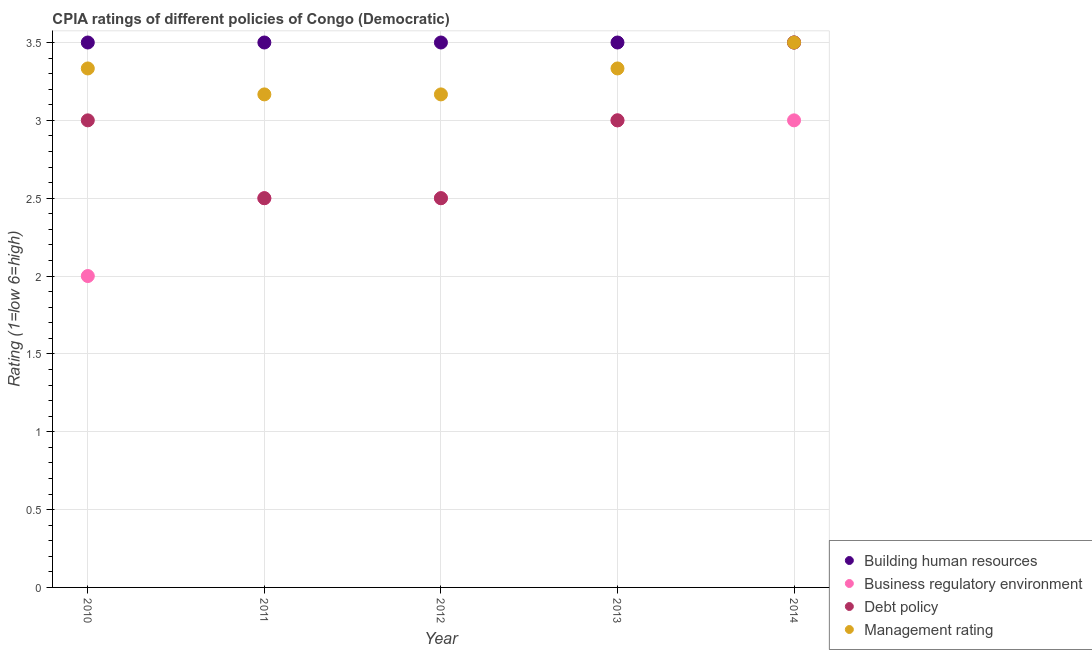How many different coloured dotlines are there?
Offer a very short reply. 4. Is the number of dotlines equal to the number of legend labels?
Your answer should be very brief. Yes. What is the cpia rating of building human resources in 2014?
Keep it short and to the point. 3.5. Across all years, what is the maximum cpia rating of business regulatory environment?
Your answer should be very brief. 3. Across all years, what is the minimum cpia rating of building human resources?
Your answer should be compact. 3.5. In which year was the cpia rating of building human resources minimum?
Make the answer very short. 2010. What is the total cpia rating of debt policy in the graph?
Provide a short and direct response. 14.5. What is the difference between the cpia rating of management in 2014 and the cpia rating of business regulatory environment in 2013?
Keep it short and to the point. 0.5. In the year 2012, what is the difference between the cpia rating of debt policy and cpia rating of building human resources?
Ensure brevity in your answer.  -1. In how many years, is the cpia rating of business regulatory environment greater than 1.2?
Provide a succinct answer. 5. What is the difference between the highest and the second highest cpia rating of management?
Offer a very short reply. 0.17. Is the sum of the cpia rating of management in 2011 and 2012 greater than the maximum cpia rating of business regulatory environment across all years?
Your answer should be compact. Yes. Does the cpia rating of management monotonically increase over the years?
Make the answer very short. No. How many dotlines are there?
Offer a terse response. 4. How many years are there in the graph?
Keep it short and to the point. 5. Are the values on the major ticks of Y-axis written in scientific E-notation?
Give a very brief answer. No. Does the graph contain any zero values?
Offer a very short reply. No. How many legend labels are there?
Provide a short and direct response. 4. What is the title of the graph?
Make the answer very short. CPIA ratings of different policies of Congo (Democratic). What is the label or title of the Y-axis?
Your response must be concise. Rating (1=low 6=high). What is the Rating (1=low 6=high) in Business regulatory environment in 2010?
Provide a succinct answer. 2. What is the Rating (1=low 6=high) of Debt policy in 2010?
Keep it short and to the point. 3. What is the Rating (1=low 6=high) of Management rating in 2010?
Keep it short and to the point. 3.33. What is the Rating (1=low 6=high) in Building human resources in 2011?
Make the answer very short. 3.5. What is the Rating (1=low 6=high) in Business regulatory environment in 2011?
Provide a succinct answer. 2.5. What is the Rating (1=low 6=high) in Debt policy in 2011?
Keep it short and to the point. 2.5. What is the Rating (1=low 6=high) of Management rating in 2011?
Provide a succinct answer. 3.17. What is the Rating (1=low 6=high) of Management rating in 2012?
Offer a terse response. 3.17. What is the Rating (1=low 6=high) in Building human resources in 2013?
Keep it short and to the point. 3.5. What is the Rating (1=low 6=high) in Business regulatory environment in 2013?
Provide a succinct answer. 3. What is the Rating (1=low 6=high) in Management rating in 2013?
Keep it short and to the point. 3.33. What is the Rating (1=low 6=high) of Building human resources in 2014?
Provide a short and direct response. 3.5. What is the Rating (1=low 6=high) of Management rating in 2014?
Your answer should be very brief. 3.5. Across all years, what is the maximum Rating (1=low 6=high) of Building human resources?
Ensure brevity in your answer.  3.5. Across all years, what is the maximum Rating (1=low 6=high) of Business regulatory environment?
Offer a terse response. 3. Across all years, what is the maximum Rating (1=low 6=high) of Debt policy?
Provide a succinct answer. 3.5. Across all years, what is the maximum Rating (1=low 6=high) of Management rating?
Make the answer very short. 3.5. Across all years, what is the minimum Rating (1=low 6=high) in Building human resources?
Provide a short and direct response. 3.5. Across all years, what is the minimum Rating (1=low 6=high) of Business regulatory environment?
Your answer should be compact. 2. Across all years, what is the minimum Rating (1=low 6=high) in Debt policy?
Provide a succinct answer. 2.5. Across all years, what is the minimum Rating (1=low 6=high) of Management rating?
Provide a short and direct response. 3.17. What is the total Rating (1=low 6=high) in Building human resources in the graph?
Make the answer very short. 17.5. What is the total Rating (1=low 6=high) of Business regulatory environment in the graph?
Offer a very short reply. 13. What is the total Rating (1=low 6=high) of Management rating in the graph?
Make the answer very short. 16.5. What is the difference between the Rating (1=low 6=high) of Business regulatory environment in 2010 and that in 2011?
Your answer should be compact. -0.5. What is the difference between the Rating (1=low 6=high) of Debt policy in 2010 and that in 2011?
Make the answer very short. 0.5. What is the difference between the Rating (1=low 6=high) of Business regulatory environment in 2010 and that in 2012?
Your answer should be compact. -0.5. What is the difference between the Rating (1=low 6=high) in Debt policy in 2010 and that in 2012?
Your answer should be compact. 0.5. What is the difference between the Rating (1=low 6=high) in Management rating in 2010 and that in 2012?
Ensure brevity in your answer.  0.17. What is the difference between the Rating (1=low 6=high) in Debt policy in 2010 and that in 2013?
Your answer should be compact. 0. What is the difference between the Rating (1=low 6=high) of Management rating in 2010 and that in 2013?
Give a very brief answer. 0. What is the difference between the Rating (1=low 6=high) of Business regulatory environment in 2010 and that in 2014?
Ensure brevity in your answer.  -1. What is the difference between the Rating (1=low 6=high) in Debt policy in 2010 and that in 2014?
Offer a very short reply. -0.5. What is the difference between the Rating (1=low 6=high) of Management rating in 2010 and that in 2014?
Give a very brief answer. -0.17. What is the difference between the Rating (1=low 6=high) in Building human resources in 2011 and that in 2012?
Your answer should be compact. 0. What is the difference between the Rating (1=low 6=high) in Business regulatory environment in 2011 and that in 2012?
Offer a very short reply. 0. What is the difference between the Rating (1=low 6=high) in Debt policy in 2011 and that in 2012?
Ensure brevity in your answer.  0. What is the difference between the Rating (1=low 6=high) of Business regulatory environment in 2011 and that in 2013?
Ensure brevity in your answer.  -0.5. What is the difference between the Rating (1=low 6=high) in Debt policy in 2011 and that in 2013?
Offer a very short reply. -0.5. What is the difference between the Rating (1=low 6=high) in Management rating in 2011 and that in 2013?
Provide a succinct answer. -0.17. What is the difference between the Rating (1=low 6=high) of Building human resources in 2011 and that in 2014?
Your answer should be very brief. 0. What is the difference between the Rating (1=low 6=high) in Management rating in 2011 and that in 2014?
Your answer should be very brief. -0.33. What is the difference between the Rating (1=low 6=high) in Management rating in 2012 and that in 2013?
Your answer should be compact. -0.17. What is the difference between the Rating (1=low 6=high) of Building human resources in 2012 and that in 2014?
Offer a terse response. 0. What is the difference between the Rating (1=low 6=high) of Debt policy in 2013 and that in 2014?
Your answer should be compact. -0.5. What is the difference between the Rating (1=low 6=high) in Management rating in 2013 and that in 2014?
Make the answer very short. -0.17. What is the difference between the Rating (1=low 6=high) of Building human resources in 2010 and the Rating (1=low 6=high) of Business regulatory environment in 2011?
Keep it short and to the point. 1. What is the difference between the Rating (1=low 6=high) in Building human resources in 2010 and the Rating (1=low 6=high) in Management rating in 2011?
Your answer should be compact. 0.33. What is the difference between the Rating (1=low 6=high) in Business regulatory environment in 2010 and the Rating (1=low 6=high) in Debt policy in 2011?
Your answer should be compact. -0.5. What is the difference between the Rating (1=low 6=high) in Business regulatory environment in 2010 and the Rating (1=low 6=high) in Management rating in 2011?
Give a very brief answer. -1.17. What is the difference between the Rating (1=low 6=high) of Building human resources in 2010 and the Rating (1=low 6=high) of Business regulatory environment in 2012?
Keep it short and to the point. 1. What is the difference between the Rating (1=low 6=high) of Building human resources in 2010 and the Rating (1=low 6=high) of Debt policy in 2012?
Ensure brevity in your answer.  1. What is the difference between the Rating (1=low 6=high) in Business regulatory environment in 2010 and the Rating (1=low 6=high) in Debt policy in 2012?
Provide a short and direct response. -0.5. What is the difference between the Rating (1=low 6=high) in Business regulatory environment in 2010 and the Rating (1=low 6=high) in Management rating in 2012?
Keep it short and to the point. -1.17. What is the difference between the Rating (1=low 6=high) of Debt policy in 2010 and the Rating (1=low 6=high) of Management rating in 2012?
Provide a succinct answer. -0.17. What is the difference between the Rating (1=low 6=high) in Building human resources in 2010 and the Rating (1=low 6=high) in Debt policy in 2013?
Your answer should be very brief. 0.5. What is the difference between the Rating (1=low 6=high) of Business regulatory environment in 2010 and the Rating (1=low 6=high) of Debt policy in 2013?
Your answer should be very brief. -1. What is the difference between the Rating (1=low 6=high) in Business regulatory environment in 2010 and the Rating (1=low 6=high) in Management rating in 2013?
Keep it short and to the point. -1.33. What is the difference between the Rating (1=low 6=high) in Building human resources in 2010 and the Rating (1=low 6=high) in Business regulatory environment in 2014?
Provide a short and direct response. 0.5. What is the difference between the Rating (1=low 6=high) of Building human resources in 2010 and the Rating (1=low 6=high) of Debt policy in 2014?
Keep it short and to the point. 0. What is the difference between the Rating (1=low 6=high) in Business regulatory environment in 2010 and the Rating (1=low 6=high) in Debt policy in 2014?
Make the answer very short. -1.5. What is the difference between the Rating (1=low 6=high) of Building human resources in 2011 and the Rating (1=low 6=high) of Management rating in 2012?
Make the answer very short. 0.33. What is the difference between the Rating (1=low 6=high) of Business regulatory environment in 2011 and the Rating (1=low 6=high) of Management rating in 2012?
Provide a short and direct response. -0.67. What is the difference between the Rating (1=low 6=high) of Building human resources in 2011 and the Rating (1=low 6=high) of Business regulatory environment in 2013?
Your response must be concise. 0.5. What is the difference between the Rating (1=low 6=high) of Building human resources in 2011 and the Rating (1=low 6=high) of Debt policy in 2013?
Ensure brevity in your answer.  0.5. What is the difference between the Rating (1=low 6=high) in Business regulatory environment in 2011 and the Rating (1=low 6=high) in Debt policy in 2013?
Provide a short and direct response. -0.5. What is the difference between the Rating (1=low 6=high) of Debt policy in 2011 and the Rating (1=low 6=high) of Management rating in 2013?
Offer a very short reply. -0.83. What is the difference between the Rating (1=low 6=high) of Building human resources in 2012 and the Rating (1=low 6=high) of Management rating in 2013?
Provide a short and direct response. 0.17. What is the difference between the Rating (1=low 6=high) in Debt policy in 2012 and the Rating (1=low 6=high) in Management rating in 2013?
Keep it short and to the point. -0.83. What is the difference between the Rating (1=low 6=high) in Business regulatory environment in 2012 and the Rating (1=low 6=high) in Debt policy in 2014?
Give a very brief answer. -1. What is the difference between the Rating (1=low 6=high) of Business regulatory environment in 2012 and the Rating (1=low 6=high) of Management rating in 2014?
Provide a succinct answer. -1. What is the difference between the Rating (1=low 6=high) of Building human resources in 2013 and the Rating (1=low 6=high) of Business regulatory environment in 2014?
Provide a succinct answer. 0.5. What is the average Rating (1=low 6=high) in Business regulatory environment per year?
Your answer should be compact. 2.6. What is the average Rating (1=low 6=high) in Debt policy per year?
Provide a succinct answer. 2.9. What is the average Rating (1=low 6=high) of Management rating per year?
Keep it short and to the point. 3.3. In the year 2010, what is the difference between the Rating (1=low 6=high) of Business regulatory environment and Rating (1=low 6=high) of Management rating?
Your response must be concise. -1.33. In the year 2010, what is the difference between the Rating (1=low 6=high) in Debt policy and Rating (1=low 6=high) in Management rating?
Ensure brevity in your answer.  -0.33. In the year 2011, what is the difference between the Rating (1=low 6=high) of Debt policy and Rating (1=low 6=high) of Management rating?
Make the answer very short. -0.67. In the year 2012, what is the difference between the Rating (1=low 6=high) in Building human resources and Rating (1=low 6=high) in Business regulatory environment?
Make the answer very short. 1. In the year 2012, what is the difference between the Rating (1=low 6=high) of Building human resources and Rating (1=low 6=high) of Debt policy?
Your answer should be very brief. 1. In the year 2012, what is the difference between the Rating (1=low 6=high) in Business regulatory environment and Rating (1=low 6=high) in Debt policy?
Ensure brevity in your answer.  0. In the year 2013, what is the difference between the Rating (1=low 6=high) in Building human resources and Rating (1=low 6=high) in Business regulatory environment?
Provide a short and direct response. 0.5. In the year 2013, what is the difference between the Rating (1=low 6=high) in Building human resources and Rating (1=low 6=high) in Debt policy?
Your answer should be very brief. 0.5. In the year 2013, what is the difference between the Rating (1=low 6=high) of Building human resources and Rating (1=low 6=high) of Management rating?
Your answer should be compact. 0.17. In the year 2013, what is the difference between the Rating (1=low 6=high) of Debt policy and Rating (1=low 6=high) of Management rating?
Offer a very short reply. -0.33. In the year 2014, what is the difference between the Rating (1=low 6=high) of Building human resources and Rating (1=low 6=high) of Management rating?
Make the answer very short. 0. In the year 2014, what is the difference between the Rating (1=low 6=high) in Business regulatory environment and Rating (1=low 6=high) in Debt policy?
Your response must be concise. -0.5. In the year 2014, what is the difference between the Rating (1=low 6=high) of Business regulatory environment and Rating (1=low 6=high) of Management rating?
Make the answer very short. -0.5. What is the ratio of the Rating (1=low 6=high) in Debt policy in 2010 to that in 2011?
Make the answer very short. 1.2. What is the ratio of the Rating (1=low 6=high) of Management rating in 2010 to that in 2011?
Give a very brief answer. 1.05. What is the ratio of the Rating (1=low 6=high) of Debt policy in 2010 to that in 2012?
Your answer should be very brief. 1.2. What is the ratio of the Rating (1=low 6=high) of Management rating in 2010 to that in 2012?
Your answer should be compact. 1.05. What is the ratio of the Rating (1=low 6=high) of Building human resources in 2010 to that in 2013?
Make the answer very short. 1. What is the ratio of the Rating (1=low 6=high) of Business regulatory environment in 2010 to that in 2013?
Ensure brevity in your answer.  0.67. What is the ratio of the Rating (1=low 6=high) of Management rating in 2010 to that in 2014?
Ensure brevity in your answer.  0.95. What is the ratio of the Rating (1=low 6=high) of Building human resources in 2011 to that in 2012?
Your response must be concise. 1. What is the ratio of the Rating (1=low 6=high) of Debt policy in 2011 to that in 2012?
Make the answer very short. 1. What is the ratio of the Rating (1=low 6=high) in Management rating in 2011 to that in 2012?
Provide a short and direct response. 1. What is the ratio of the Rating (1=low 6=high) of Business regulatory environment in 2011 to that in 2013?
Offer a terse response. 0.83. What is the ratio of the Rating (1=low 6=high) of Debt policy in 2011 to that in 2013?
Provide a short and direct response. 0.83. What is the ratio of the Rating (1=low 6=high) of Building human resources in 2011 to that in 2014?
Your answer should be compact. 1. What is the ratio of the Rating (1=low 6=high) of Business regulatory environment in 2011 to that in 2014?
Give a very brief answer. 0.83. What is the ratio of the Rating (1=low 6=high) in Debt policy in 2011 to that in 2014?
Offer a terse response. 0.71. What is the ratio of the Rating (1=low 6=high) in Management rating in 2011 to that in 2014?
Offer a terse response. 0.9. What is the ratio of the Rating (1=low 6=high) of Debt policy in 2012 to that in 2013?
Your answer should be compact. 0.83. What is the ratio of the Rating (1=low 6=high) of Building human resources in 2012 to that in 2014?
Ensure brevity in your answer.  1. What is the ratio of the Rating (1=low 6=high) in Debt policy in 2012 to that in 2014?
Keep it short and to the point. 0.71. What is the ratio of the Rating (1=low 6=high) of Management rating in 2012 to that in 2014?
Offer a terse response. 0.9. What is the ratio of the Rating (1=low 6=high) in Business regulatory environment in 2013 to that in 2014?
Give a very brief answer. 1. What is the ratio of the Rating (1=low 6=high) of Management rating in 2013 to that in 2014?
Make the answer very short. 0.95. What is the difference between the highest and the second highest Rating (1=low 6=high) of Building human resources?
Provide a succinct answer. 0. What is the difference between the highest and the second highest Rating (1=low 6=high) of Debt policy?
Your response must be concise. 0.5. What is the difference between the highest and the second highest Rating (1=low 6=high) in Management rating?
Your response must be concise. 0.17. What is the difference between the highest and the lowest Rating (1=low 6=high) of Management rating?
Your answer should be compact. 0.33. 